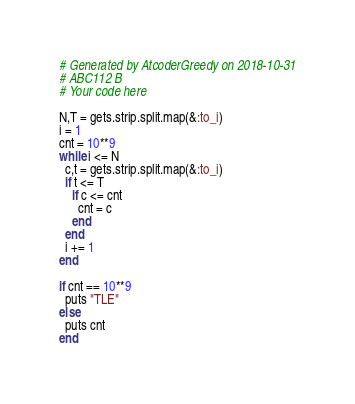Convert code to text. <code><loc_0><loc_0><loc_500><loc_500><_Ruby_># Generated by AtcoderGreedy on 2018-10-31
# ABC112 B
# Your code here

N,T = gets.strip.split.map(&:to_i)
i = 1
cnt = 10**9
while i <= N
  c,t = gets.strip.split.map(&:to_i)
  if t <= T
    if c <= cnt
      cnt = c
    end
  end
  i += 1
end

if cnt == 10**9
  puts "TLE"
else
  puts cnt
end
</code> 